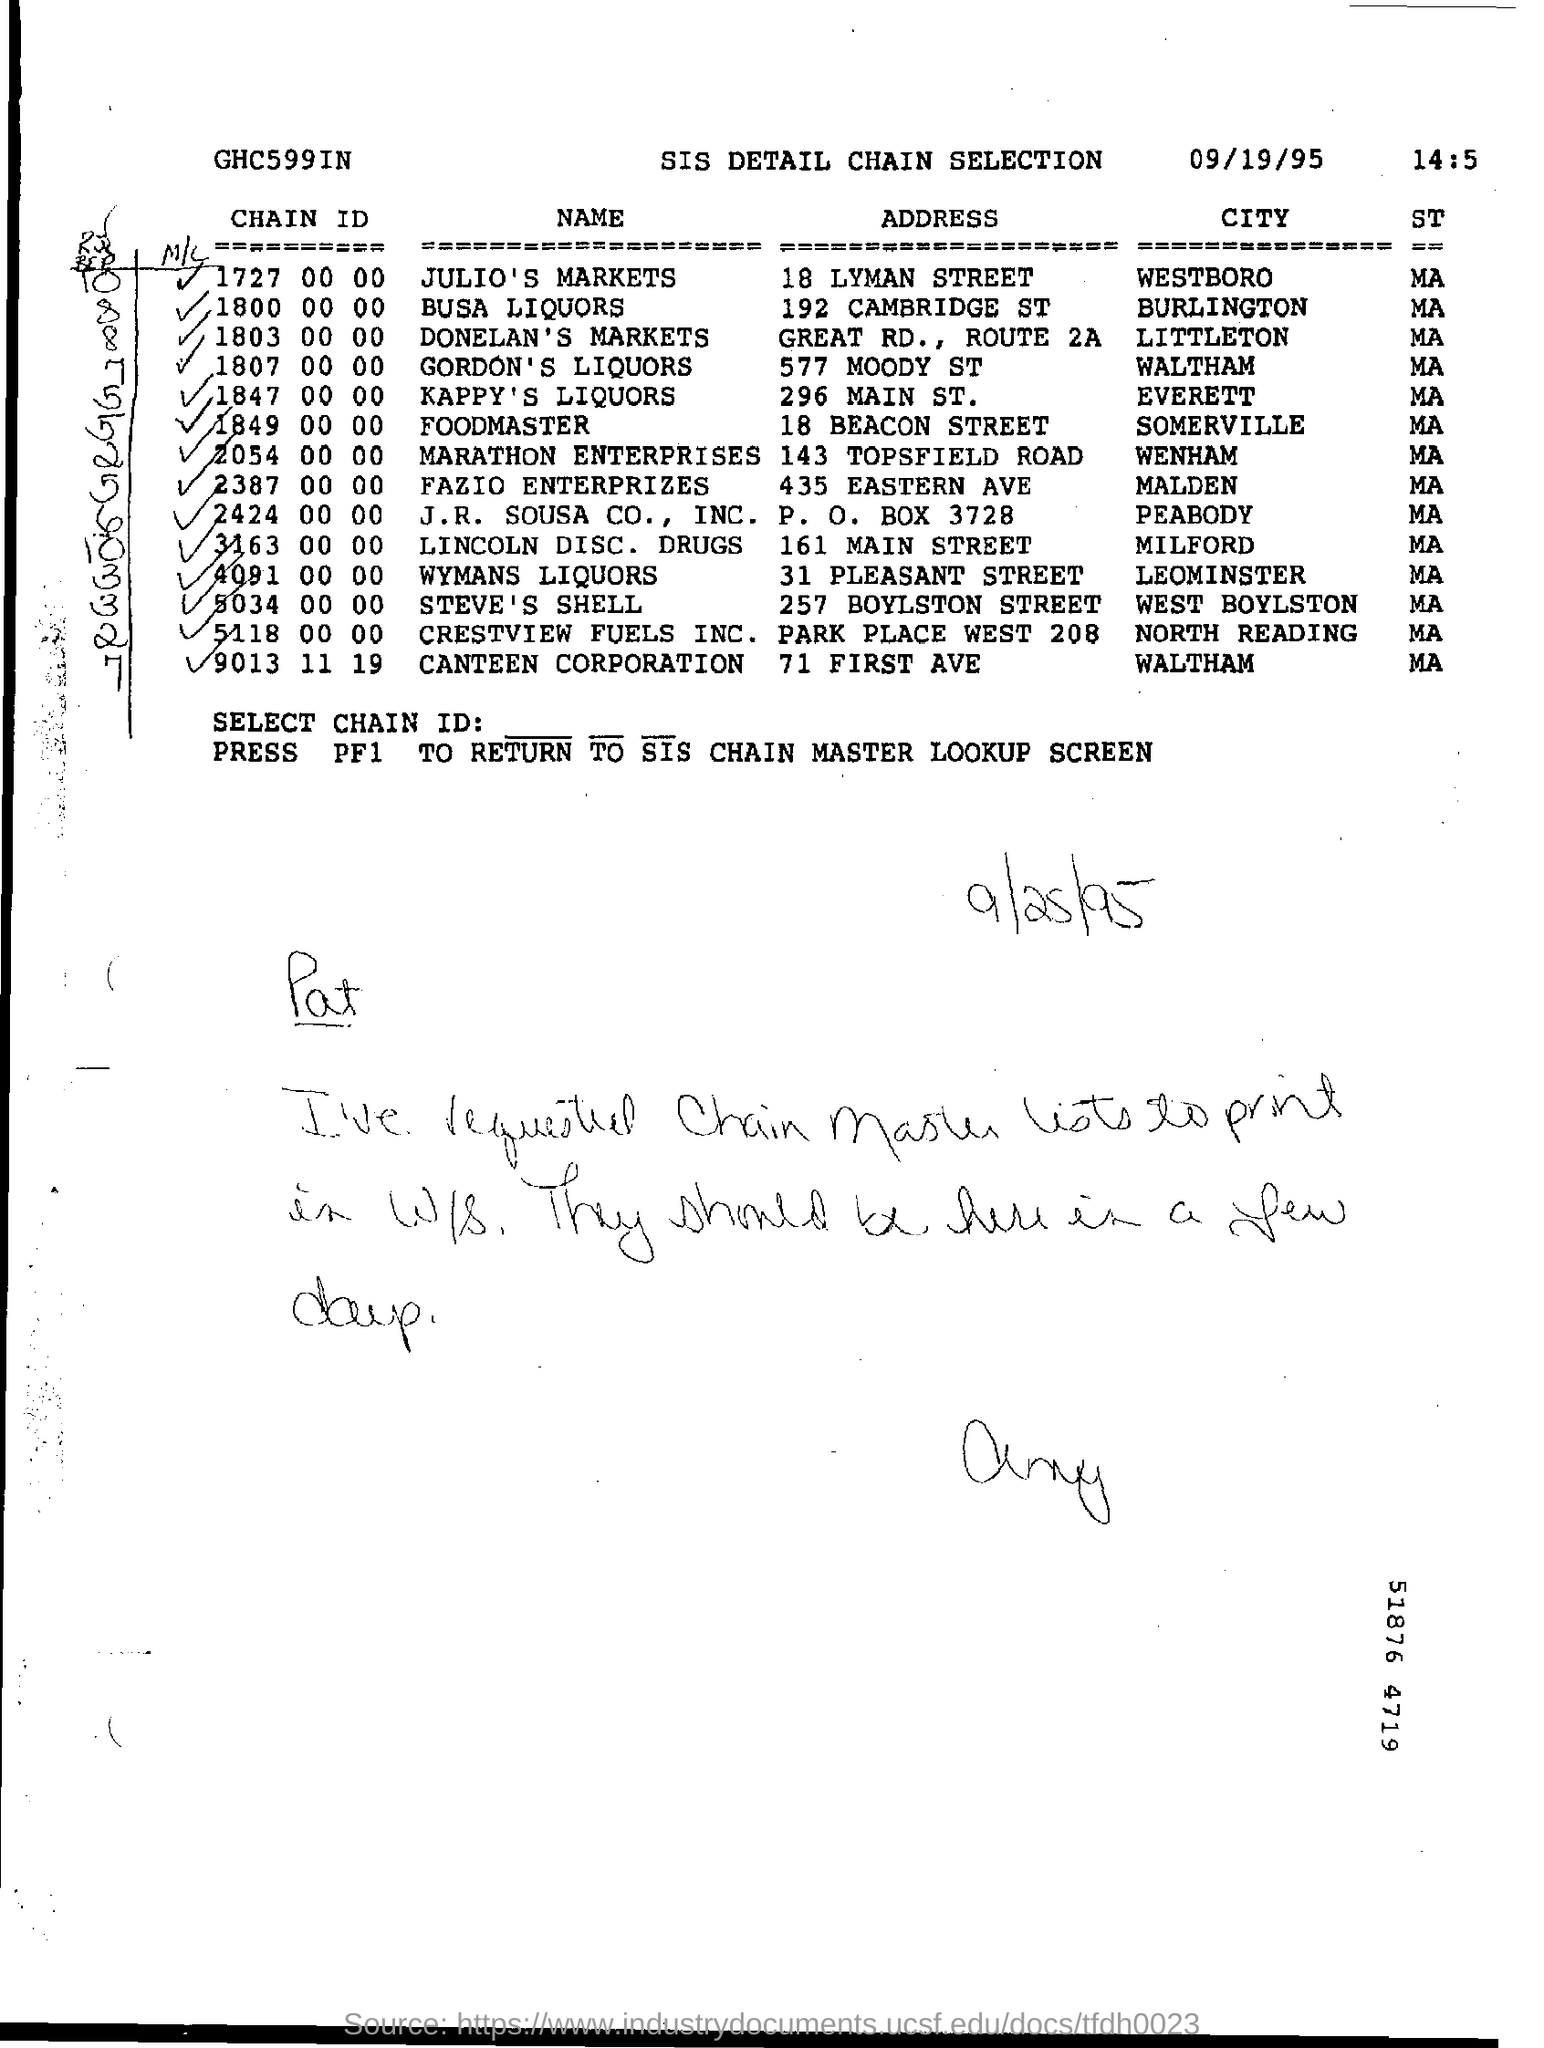What is the month mentioned in the chain selection?
Provide a succinct answer. 09. 9013 11  19 is the chain Id for which address and city?
Your answer should be compact. 71 FIRST AVE ,WALTHAM. 